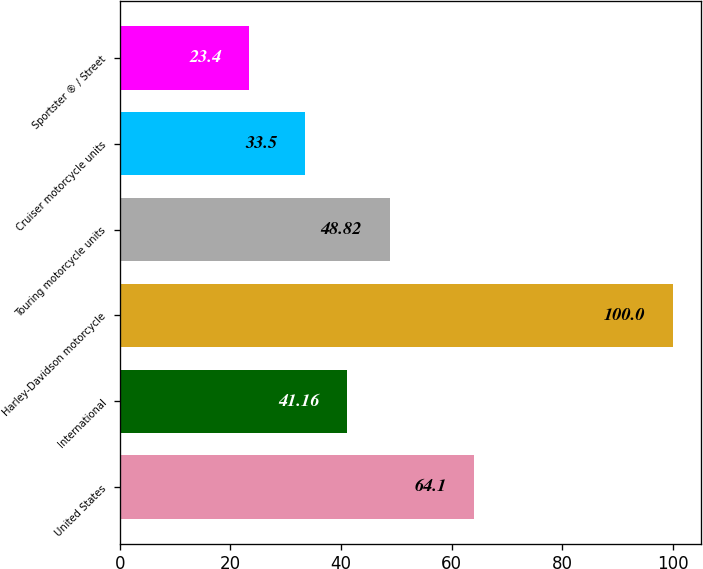Convert chart. <chart><loc_0><loc_0><loc_500><loc_500><bar_chart><fcel>United States<fcel>International<fcel>Harley-Davidson motorcycle<fcel>Touring motorcycle units<fcel>Cruiser motorcycle units<fcel>Sportster ® / Street<nl><fcel>64.1<fcel>41.16<fcel>100<fcel>48.82<fcel>33.5<fcel>23.4<nl></chart> 